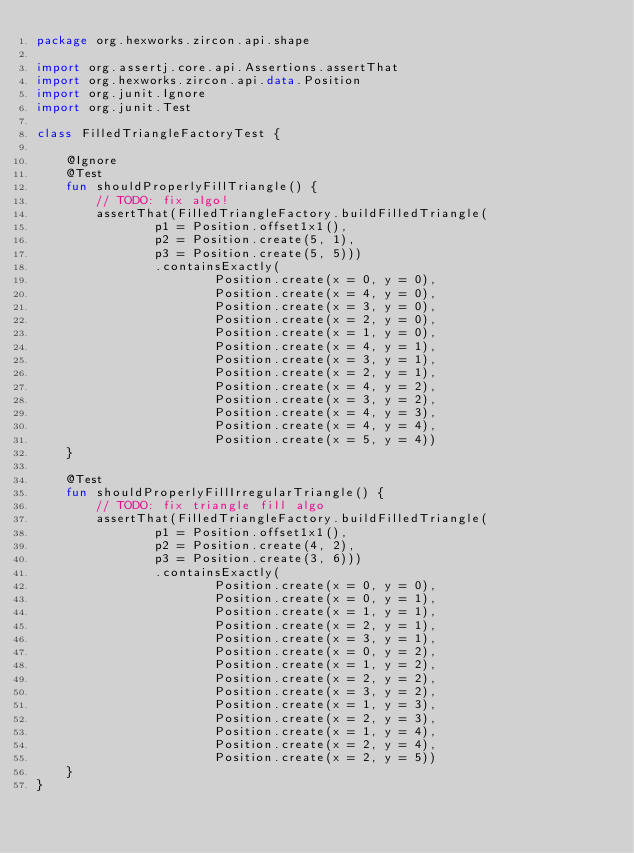Convert code to text. <code><loc_0><loc_0><loc_500><loc_500><_Kotlin_>package org.hexworks.zircon.api.shape

import org.assertj.core.api.Assertions.assertThat
import org.hexworks.zircon.api.data.Position
import org.junit.Ignore
import org.junit.Test

class FilledTriangleFactoryTest {

    @Ignore
    @Test
    fun shouldProperlyFillTriangle() {
        // TODO: fix algo!
        assertThat(FilledTriangleFactory.buildFilledTriangle(
                p1 = Position.offset1x1(),
                p2 = Position.create(5, 1),
                p3 = Position.create(5, 5)))
                .containsExactly(
                        Position.create(x = 0, y = 0),
                        Position.create(x = 4, y = 0),
                        Position.create(x = 3, y = 0),
                        Position.create(x = 2, y = 0),
                        Position.create(x = 1, y = 0),
                        Position.create(x = 4, y = 1),
                        Position.create(x = 3, y = 1),
                        Position.create(x = 2, y = 1),
                        Position.create(x = 4, y = 2),
                        Position.create(x = 3, y = 2),
                        Position.create(x = 4, y = 3),
                        Position.create(x = 4, y = 4),
                        Position.create(x = 5, y = 4))
    }

    @Test
    fun shouldProperlyFillIrregularTriangle() {
        // TODO: fix triangle fill algo
        assertThat(FilledTriangleFactory.buildFilledTriangle(
                p1 = Position.offset1x1(),
                p2 = Position.create(4, 2),
                p3 = Position.create(3, 6)))
                .containsExactly(
                        Position.create(x = 0, y = 0),
                        Position.create(x = 0, y = 1),
                        Position.create(x = 1, y = 1),
                        Position.create(x = 2, y = 1),
                        Position.create(x = 3, y = 1),
                        Position.create(x = 0, y = 2),
                        Position.create(x = 1, y = 2),
                        Position.create(x = 2, y = 2),
                        Position.create(x = 3, y = 2),
                        Position.create(x = 1, y = 3),
                        Position.create(x = 2, y = 3),
                        Position.create(x = 1, y = 4),
                        Position.create(x = 2, y = 4),
                        Position.create(x = 2, y = 5))
    }
}
</code> 